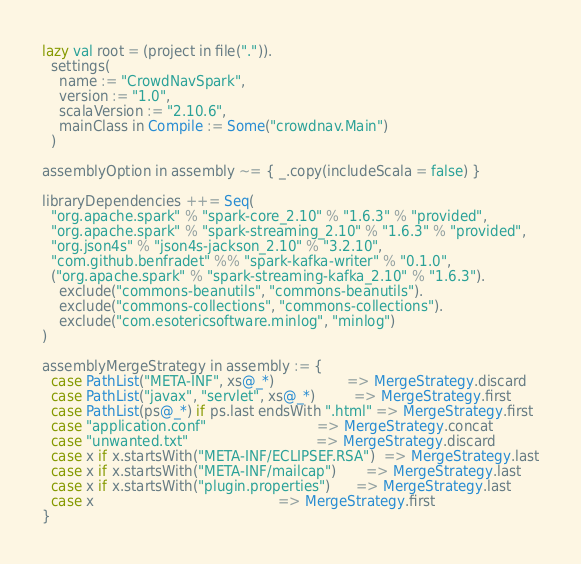<code> <loc_0><loc_0><loc_500><loc_500><_Scala_>lazy val root = (project in file(".")).
  settings(
    name := "CrowdNavSpark",
    version := "1.0",
    scalaVersion := "2.10.6",
    mainClass in Compile := Some("crowdnav.Main")
  )

assemblyOption in assembly ~= { _.copy(includeScala = false) }

libraryDependencies ++= Seq(
  "org.apache.spark" % "spark-core_2.10" % "1.6.3" % "provided",
  "org.apache.spark" % "spark-streaming_2.10" % "1.6.3" % "provided",
  "org.json4s" % "json4s-jackson_2.10" % "3.2.10",
  "com.github.benfradet" %% "spark-kafka-writer" % "0.1.0",
  ("org.apache.spark" % "spark-streaming-kafka_2.10" % "1.6.3").
    exclude("commons-beanutils", "commons-beanutils").
    exclude("commons-collections", "commons-collections").
    exclude("com.esotericsoftware.minlog", "minlog")
)

assemblyMergeStrategy in assembly := {
  case PathList("META-INF", xs@_*)                 => MergeStrategy.discard
  case PathList("javax", "servlet", xs@_*)         => MergeStrategy.first
  case PathList(ps@_*) if ps.last endsWith ".html" => MergeStrategy.first
  case "application.conf"                          => MergeStrategy.concat
  case "unwanted.txt"                              => MergeStrategy.discard
  case x if x.startsWith("META-INF/ECLIPSEF.RSA")  => MergeStrategy.last
  case x if x.startsWith("META-INF/mailcap")       => MergeStrategy.last
  case x if x.startsWith("plugin.properties")      => MergeStrategy.last
  case x                                           => MergeStrategy.first
}
</code> 